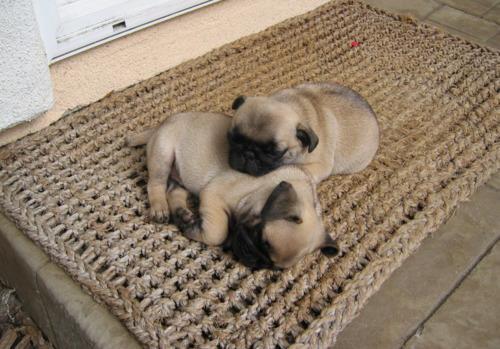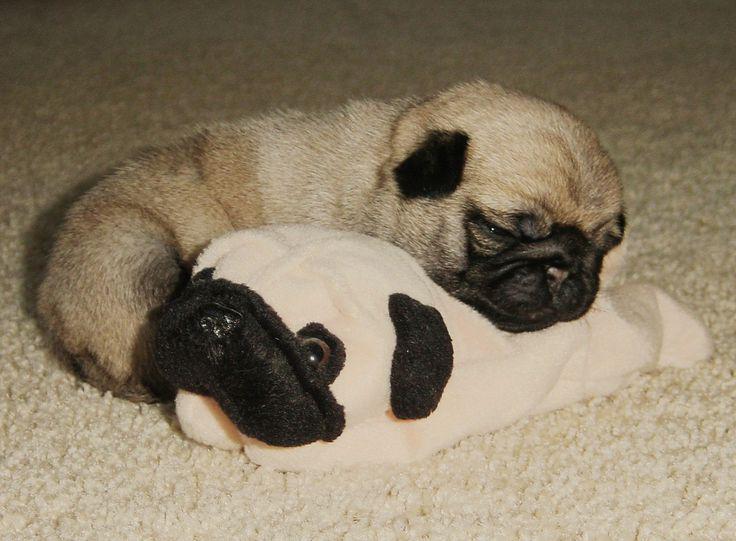The first image is the image on the left, the second image is the image on the right. Considering the images on both sides, is "There is exactly 1 puppy lying down in the image on the left." valid? Answer yes or no. No. The first image is the image on the left, the second image is the image on the right. Considering the images on both sides, is "One image shows a pug puppy with its head resting on the fur of a real animal, and the other image shows one real pug with its head resting on something plush." valid? Answer yes or no. Yes. 